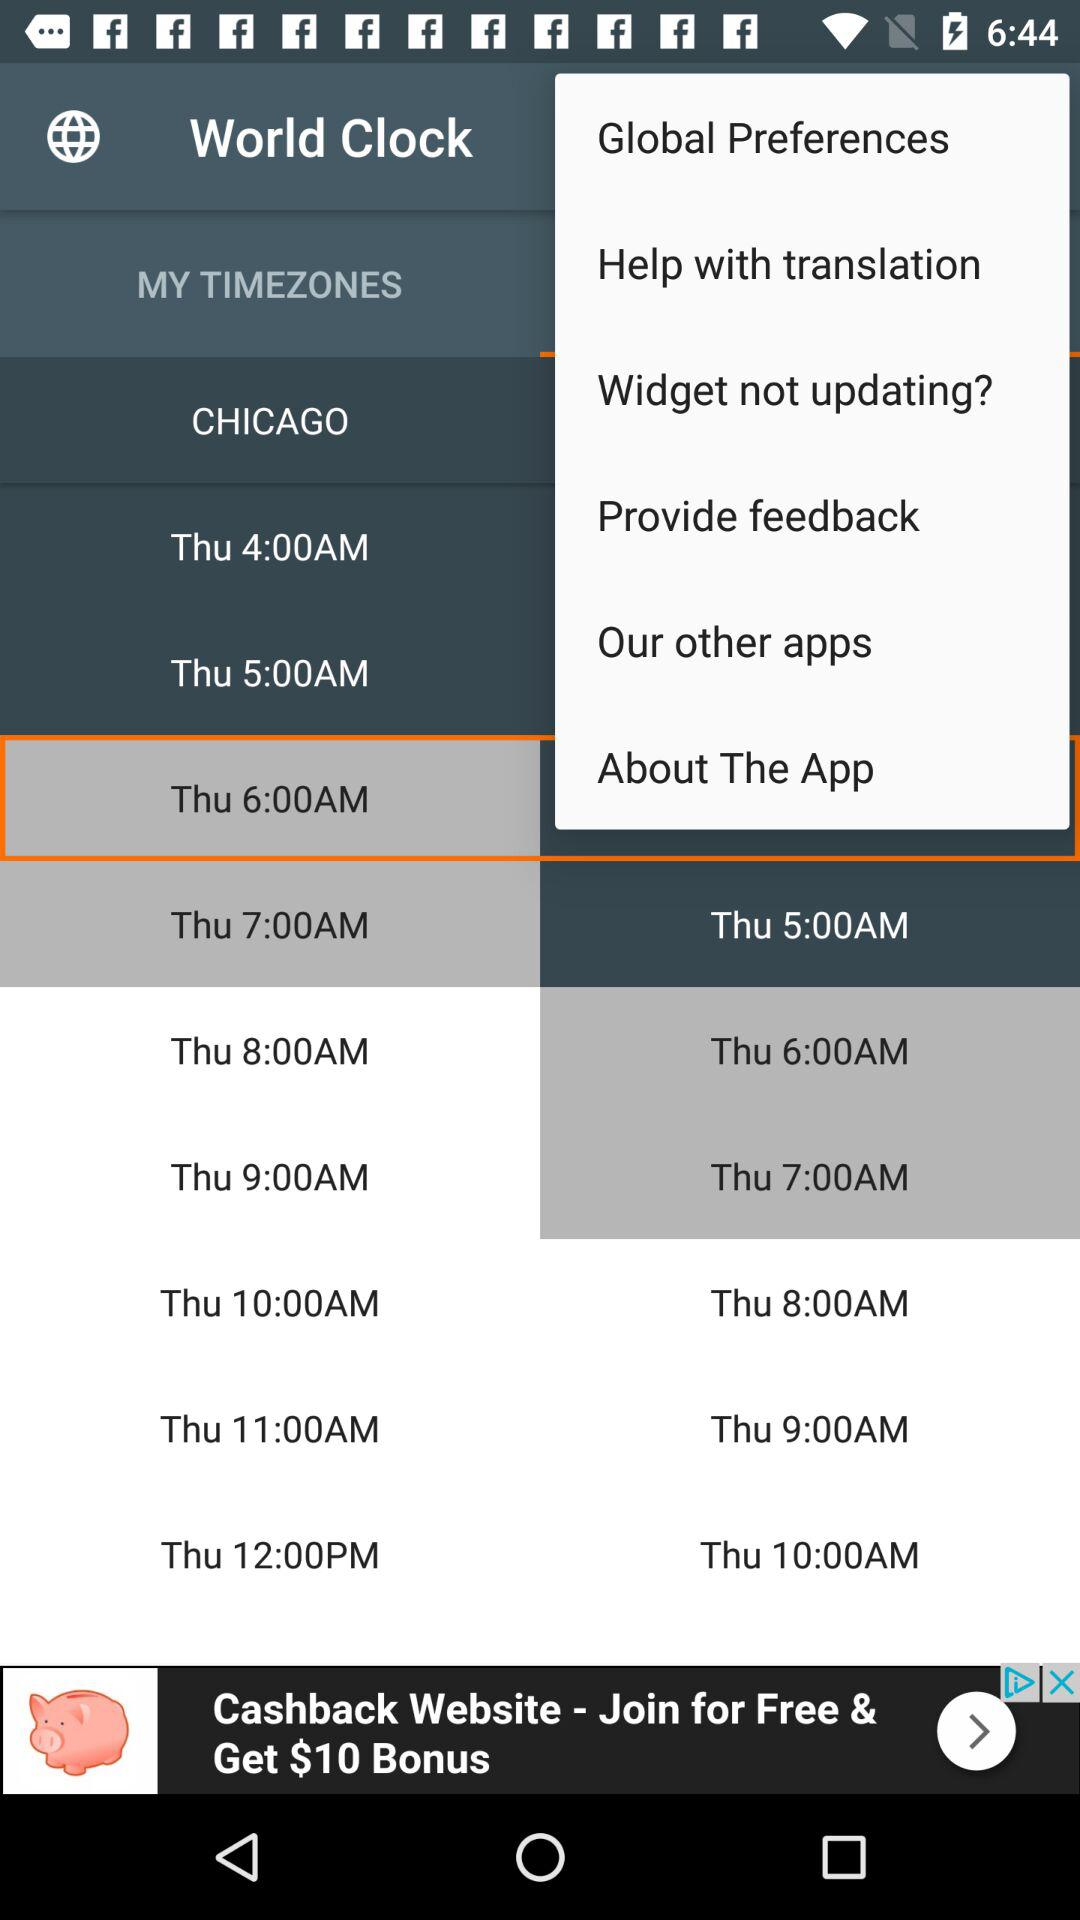What is the name of the application? The name of the application is "World Clock". 